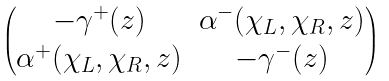<formula> <loc_0><loc_0><loc_500><loc_500>\begin{pmatrix} - \gamma ^ { + } ( z ) & \alpha ^ { - } ( \chi _ { L } , \chi _ { R } , z ) \\ \alpha ^ { + } ( \chi _ { L } , \chi _ { R } , z ) & - \gamma ^ { - } ( z ) \\ \end{pmatrix}</formula> 